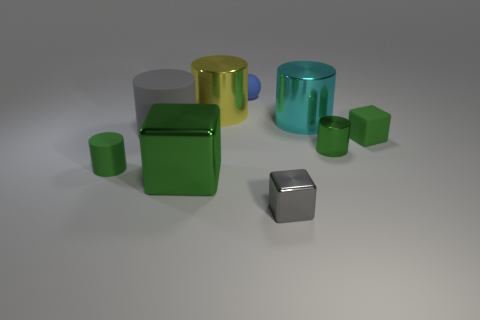Can you describe the texture and color of the objects in the image? The objects in the image appear to have a smooth and shiny texture indicative of a metallic surface. The colors present include green, blue, yellow, and grey; each color has a reflective quality, suggesting that the objects are likely made of metal with a glossy finish. 